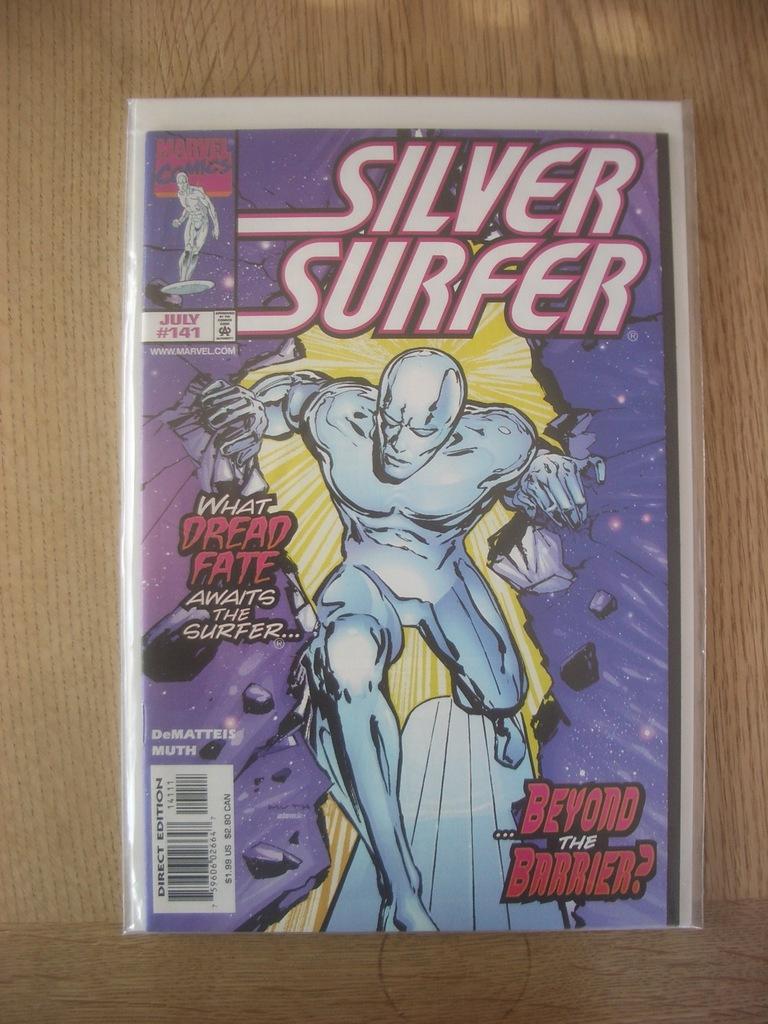Please provide a concise description of this image. In the image on the wooden surface there is a poster. On the poster there is a person and also at the bottom left corner of the image there is a barcode sticker. On the poster there is something written on it. 